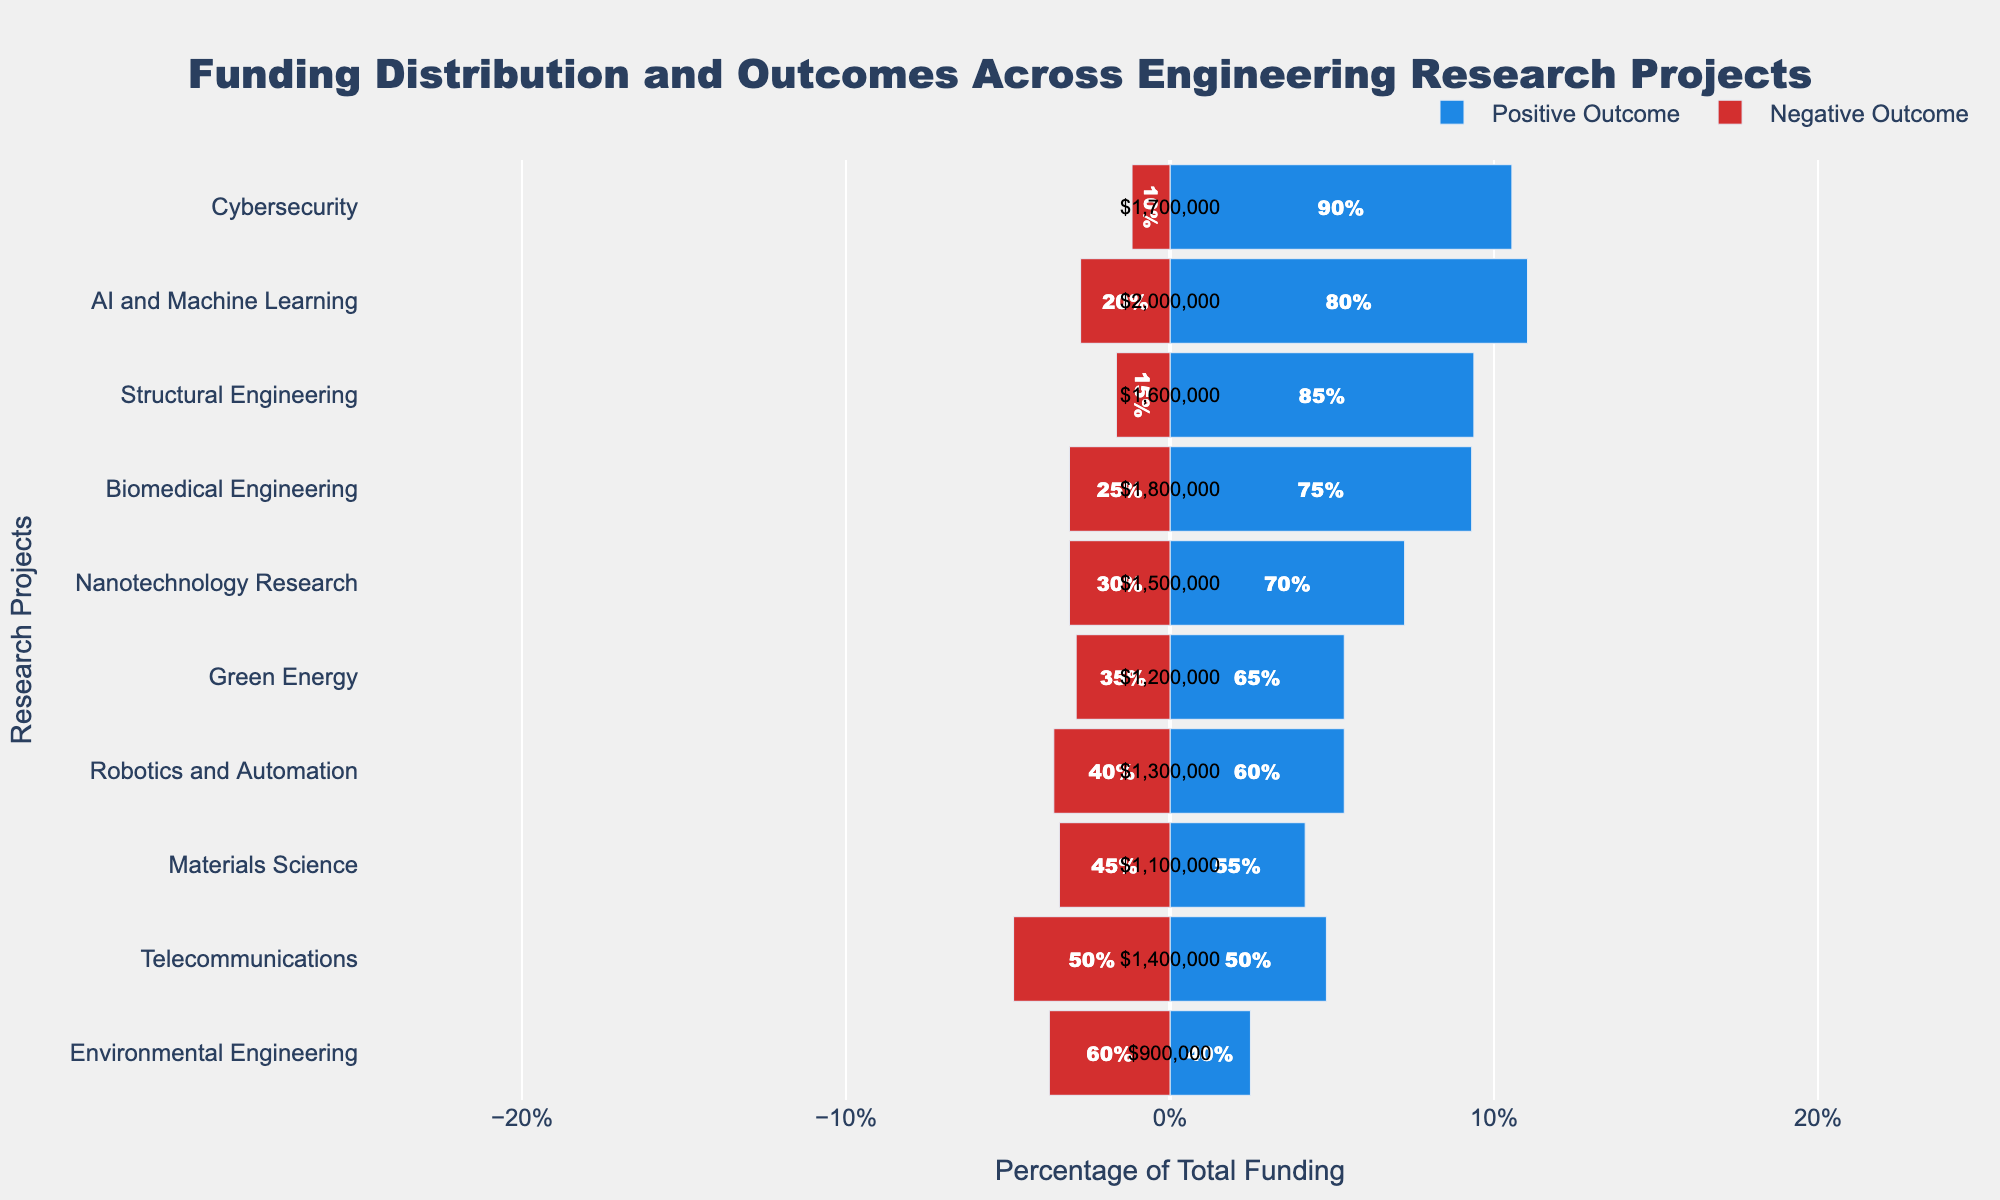What's the total percentage of positive outcomes for projects under $1,500,000 funding? First, identify the projects with funding under $1,500,000: Green Energy (65%), Robotics and Automation (60%), Materials Science (55%), Telecommunications (50%), and Environmental Engineering (40%). Sum these percentages: 65 + 60 + 55 + 50 + 40 = 270. So, the total percentage is 270%.
Answer: 270% Which project has the highest positive outcome percentage, and what is the value? Observe the positive outcome percentage from the figure: Cybersecurity has the highest with 90%.
Answer: Cybersecurity, 90% Compare the positive outcomes between AI and Machine Learning and Green Energy. Which one has a higher percentage? From the figure, AI and Machine Learning has 80% positive outcomes, and Green Energy has 65% positive outcomes. AI and Machine Learning has a higher percentage.
Answer: AI and Machine Learning What is the difference in negative outcome percentage between Telecommunications and Structural Engineering? From the figure, Telecommunications has a 50% negative outcome, and Structural Engineering has a 15% negative outcome. The difference is 50 - 15 = 35%.
Answer: 35% Which project has both the highest funding and highest percentage of positive outcomes? The figure shows that AI and Machine Learning has the highest funding of $2,000,000 and a high positive outcome percentage (80%), but Cybersecurity has the highest positive outcome (90%) with $1,700,000 funding. So, we consider AI and Machine Learning for highest funding and Cybersecurity for highest positive outcomes. Verify: the highest funding, AI and Machine Learning second highest positive outcome (80%). For highest positive outcomes, Cybersecurity has a 90% positive outcome.
Answer: Cybersecurity Which project has an equal proportion of positive and negative outcomes? From the figure, Telecommunications is the project showing an equal 50% positive outcome and 50% negative outcome.
Answer: Telecommunications Identify the project with the lowest negative outcome and specify the funding amount. The project with the lowest negative outcome is Cybersecurity with 10%. From the figure, the funding amount for Cybersecurity is $1,700,000.
Answer: Cybersecurity, $1,700,000 Determine the combined positive outcome percentage of Nanotechnology Research and Structural Engineering. From the figure, Nanotechnology Research has a 70% positive outcome, and Structural Engineering has an 85% positive outcome. The combined percentage is 70 + 85 = 155%.
Answer: 155% How many projects have a negative outcome percentage greater than 30%? From the figure, the projects are: Nanotechnology Research (30%), Green Energy (35%), Robotics and Automation (40%), Materials Science (45%), Telecommunications (50%), and Environmental Engineering (60%). Count them: 6 projects.
Answer: 6 projects 